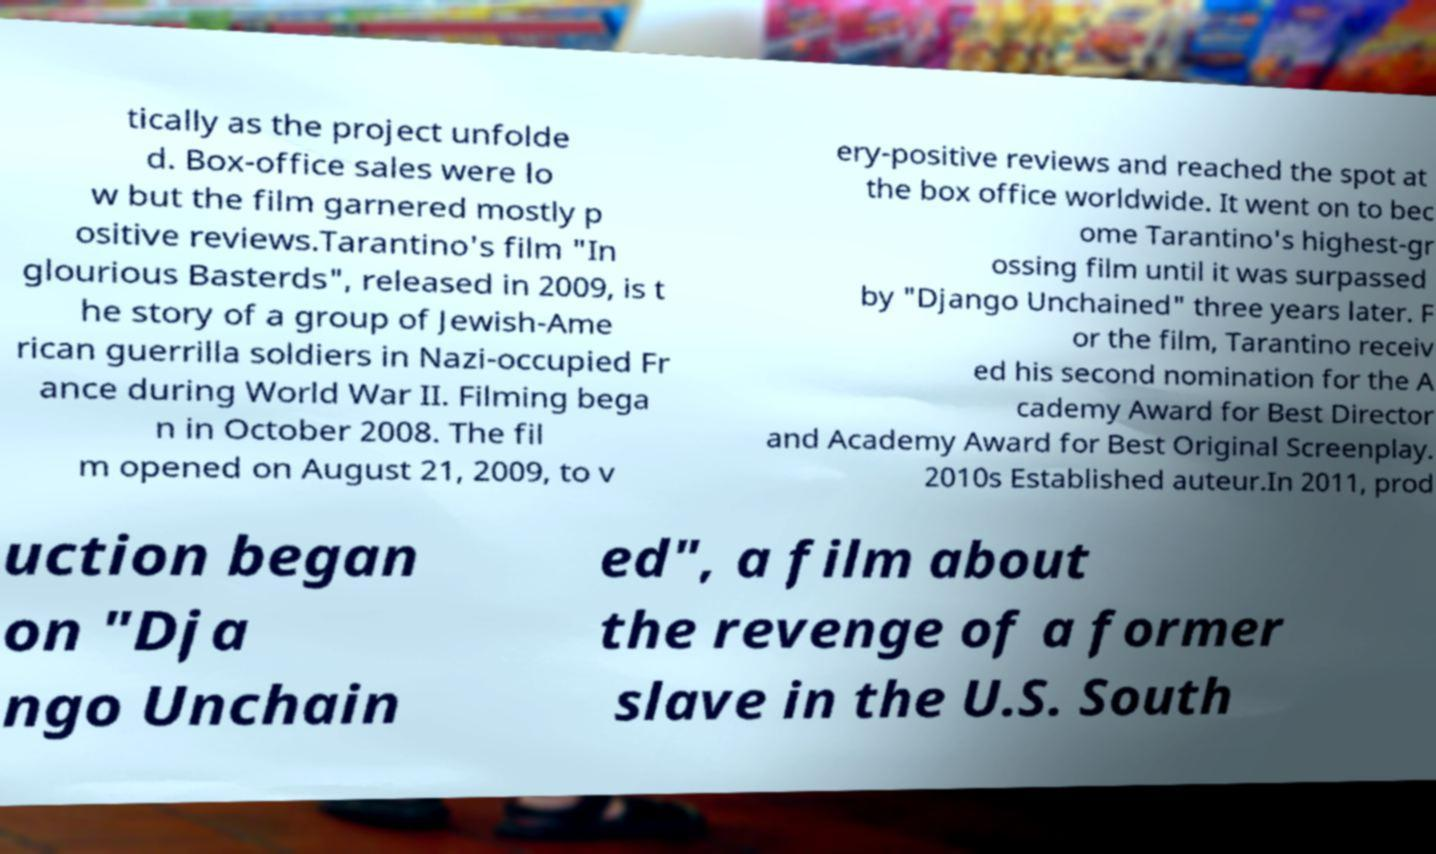I need the written content from this picture converted into text. Can you do that? tically as the project unfolde d. Box-office sales were lo w but the film garnered mostly p ositive reviews.Tarantino's film "In glourious Basterds", released in 2009, is t he story of a group of Jewish-Ame rican guerrilla soldiers in Nazi-occupied Fr ance during World War II. Filming bega n in October 2008. The fil m opened on August 21, 2009, to v ery-positive reviews and reached the spot at the box office worldwide. It went on to bec ome Tarantino's highest-gr ossing film until it was surpassed by "Django Unchained" three years later. F or the film, Tarantino receiv ed his second nomination for the A cademy Award for Best Director and Academy Award for Best Original Screenplay. 2010s Established auteur.In 2011, prod uction began on "Dja ngo Unchain ed", a film about the revenge of a former slave in the U.S. South 